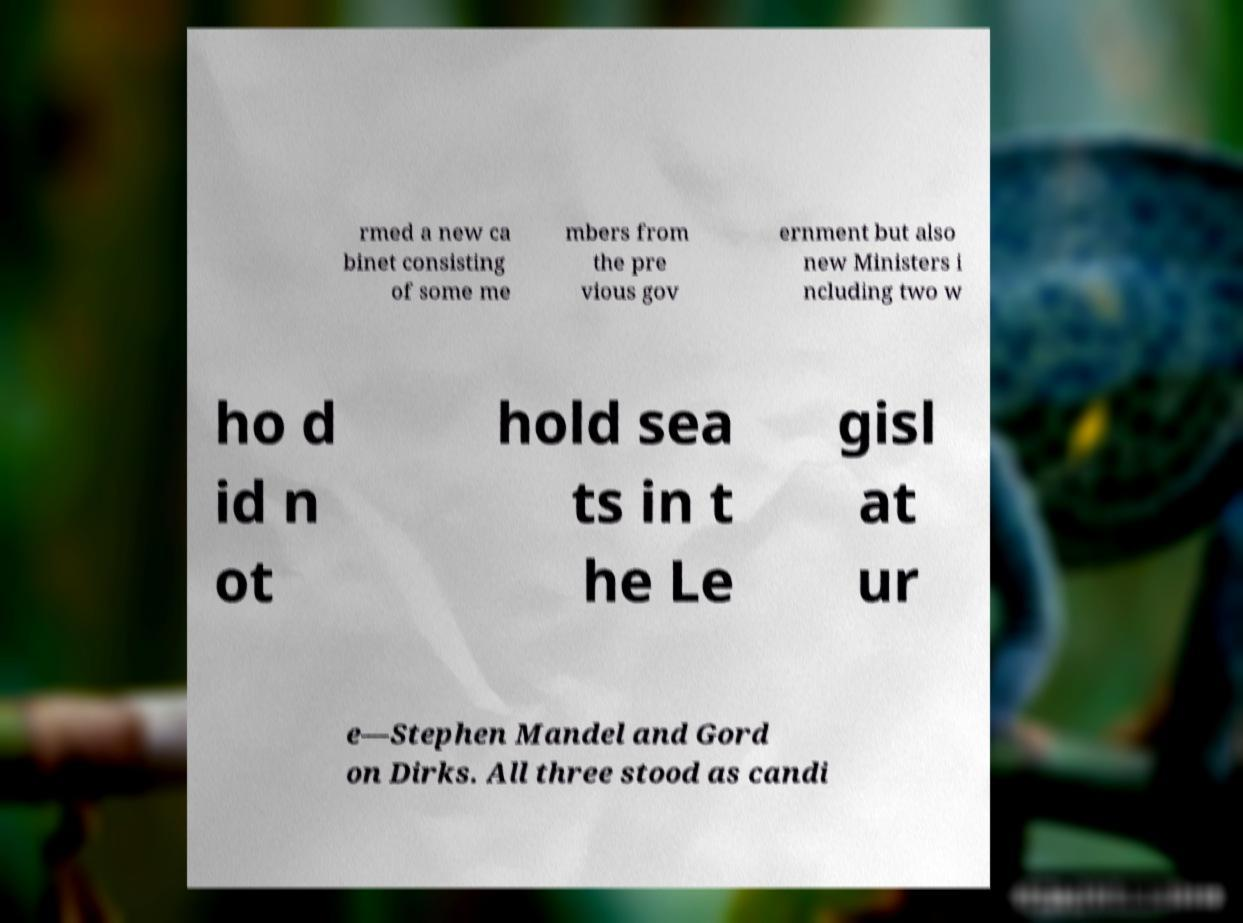Can you accurately transcribe the text from the provided image for me? rmed a new ca binet consisting of some me mbers from the pre vious gov ernment but also new Ministers i ncluding two w ho d id n ot hold sea ts in t he Le gisl at ur e—Stephen Mandel and Gord on Dirks. All three stood as candi 